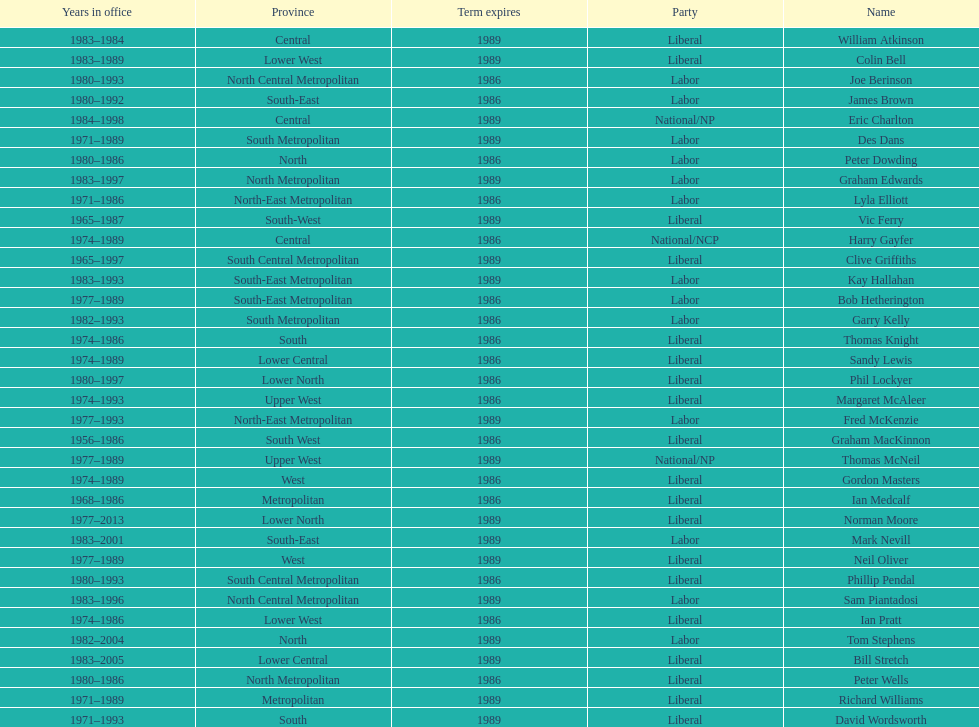Which party has the most membership? Liberal. 